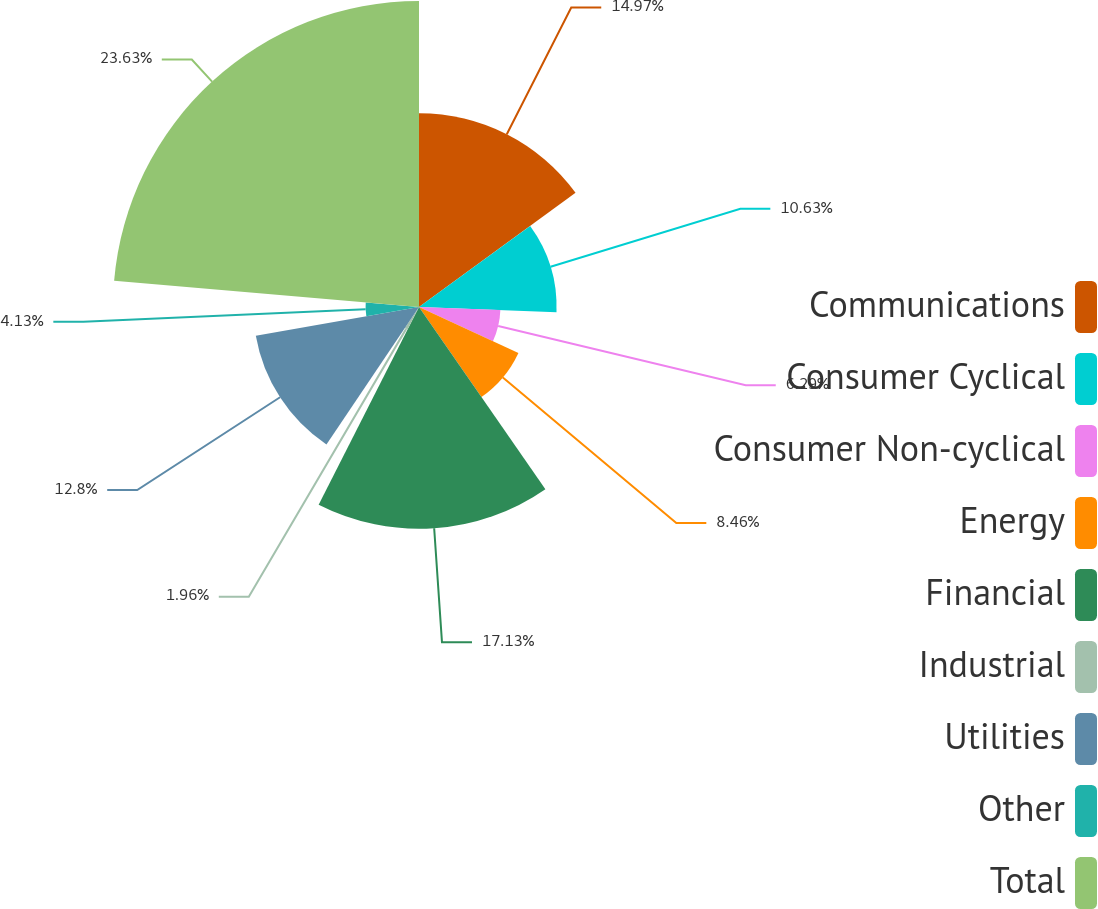Convert chart to OTSL. <chart><loc_0><loc_0><loc_500><loc_500><pie_chart><fcel>Communications<fcel>Consumer Cyclical<fcel>Consumer Non-cyclical<fcel>Energy<fcel>Financial<fcel>Industrial<fcel>Utilities<fcel>Other<fcel>Total<nl><fcel>14.97%<fcel>10.63%<fcel>6.29%<fcel>8.46%<fcel>17.13%<fcel>1.96%<fcel>12.8%<fcel>4.13%<fcel>23.64%<nl></chart> 